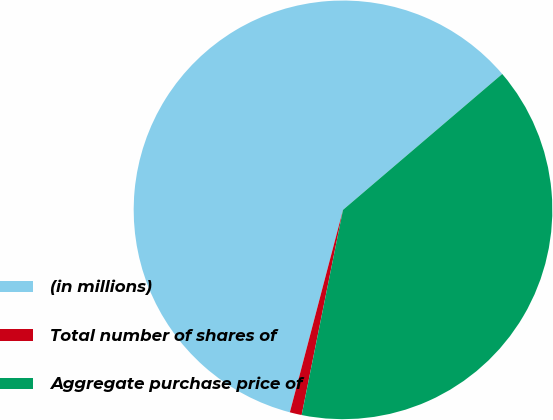Convert chart to OTSL. <chart><loc_0><loc_0><loc_500><loc_500><pie_chart><fcel>(in millions)<fcel>Total number of shares of<fcel>Aggregate purchase price of<nl><fcel>59.67%<fcel>0.92%<fcel>39.41%<nl></chart> 